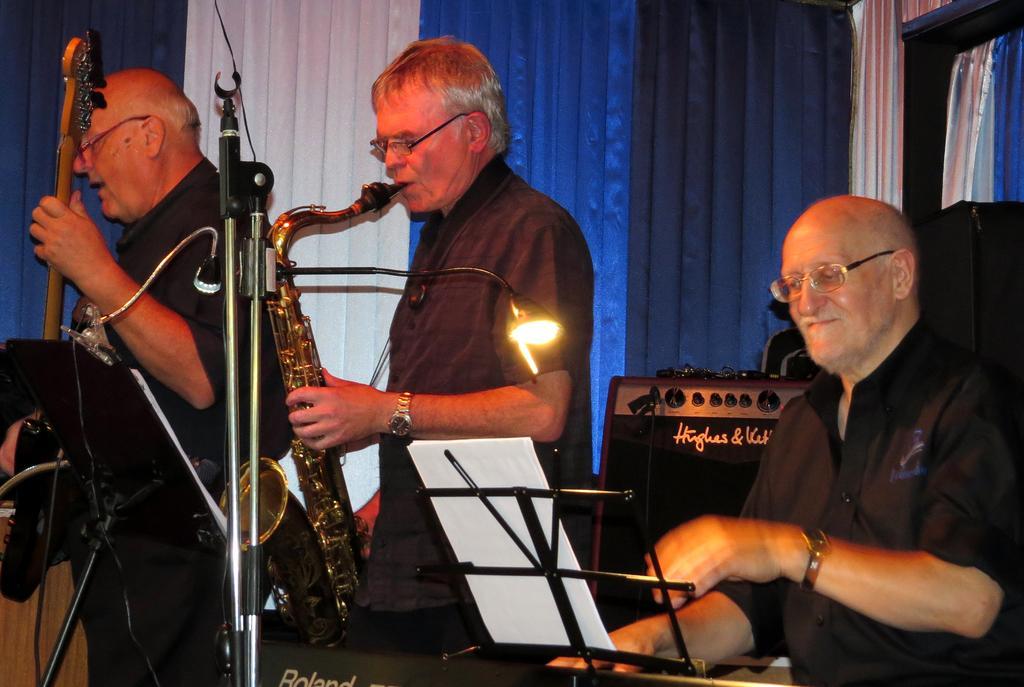Can you describe this image briefly? In this image we can see musical Instruments playing by musicians. There are colorful curtains in the background. 